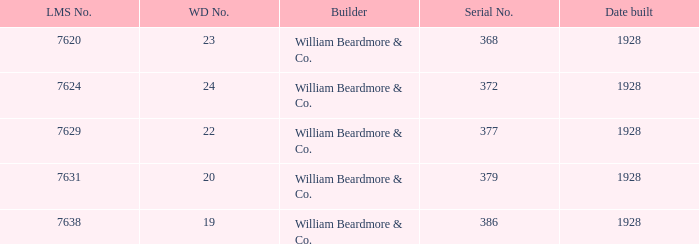Specify the complete count of wd numeral for lms value equaling 763 1.0. 